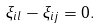<formula> <loc_0><loc_0><loc_500><loc_500>\xi _ { i l } - \xi _ { i j } = 0 .</formula> 